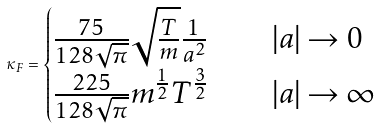Convert formula to latex. <formula><loc_0><loc_0><loc_500><loc_500>\kappa _ { F } = \begin{cases} \frac { 7 5 } { 1 2 8 \sqrt { \pi } } \sqrt { \frac { T } { m } } \frac { 1 } { a ^ { 2 } } & \quad | a | \rightarrow 0 \\ \frac { 2 2 5 } { 1 2 8 \sqrt { \pi } } m ^ { \frac { 1 } { 2 } } T ^ { \frac { 3 } { 2 } } & \quad | a | \rightarrow \infty \end{cases}</formula> 